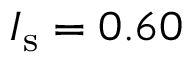Convert formula to latex. <formula><loc_0><loc_0><loc_500><loc_500>I _ { s } = 0 . 6 0</formula> 